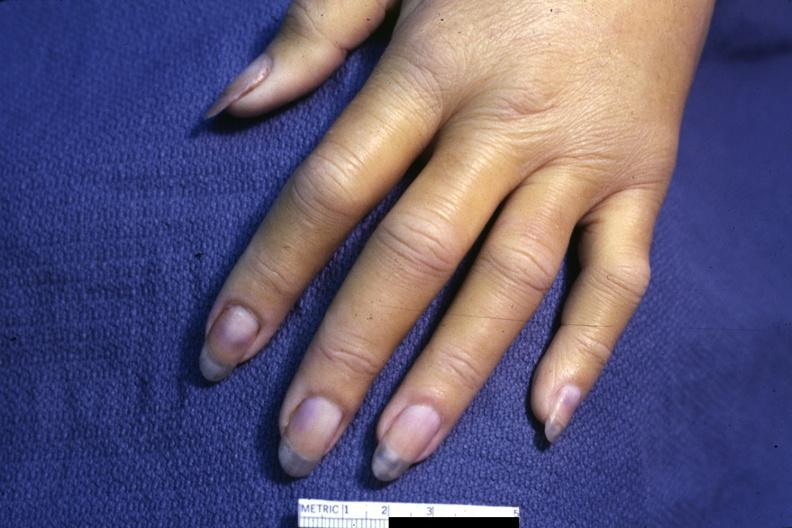what is present?
Answer the question using a single word or phrase. Hand 